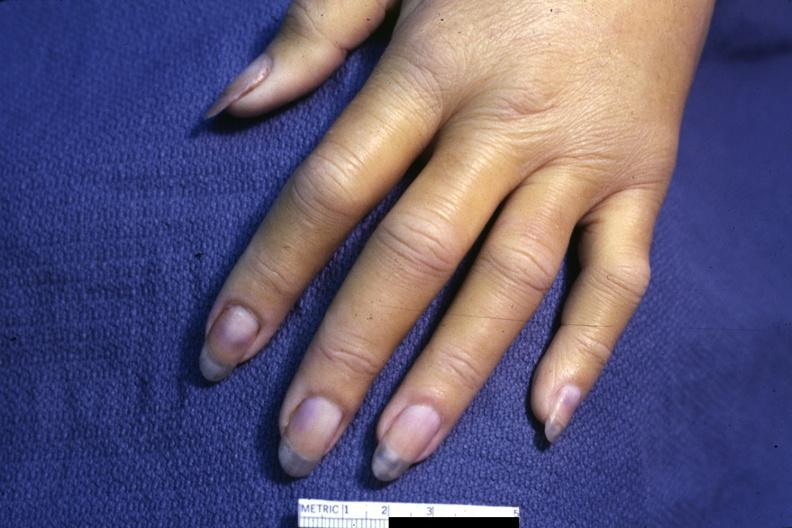what is present?
Answer the question using a single word or phrase. Hand 